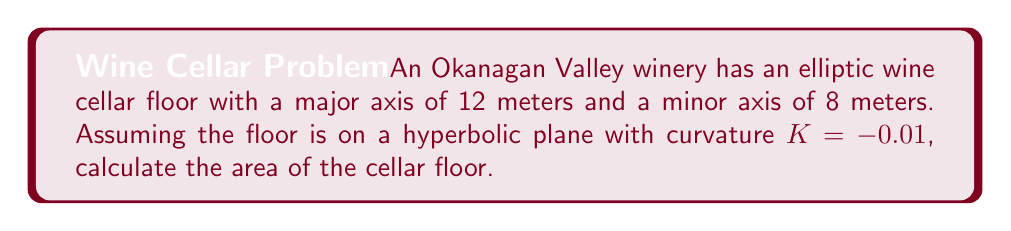Give your solution to this math problem. To calculate the area of an ellipse on a hyperbolic plane, we'll use the following steps:

1) First, recall the formula for the area of an ellipse on a hyperbolic plane with curvature $K$:

   $$A = \frac{4\pi}{|K|} \sinh(\frac{|K|ab}{4})$$

   Where $a$ and $b$ are the semi-major and semi-minor axes respectively.

2) We're given:
   - Major axis = 12 m, so $a = 6$ m
   - Minor axis = 8 m, so $b = 4$ m
   - Curvature $K = -0.01$

3) Let's substitute these values into our formula:

   $$A = \frac{4\pi}{|-0.01|} \sinh(\frac{|-0.01| \cdot 6 \cdot 4}{4})$$

4) Simplify:
   $$A = 400\pi \sinh(0.06)$$

5) Calculate the sinh value:
   $$\sinh(0.06) \approx 0.06001667$$

6) Multiply:
   $$A \approx 400\pi \cdot 0.06001667 \approx 75.39 \text{ m}^2$$

Therefore, the area of the elliptic wine cellar floor on this hyperbolic plane is approximately 75.39 square meters.
Answer: $75.39 \text{ m}^2$ 